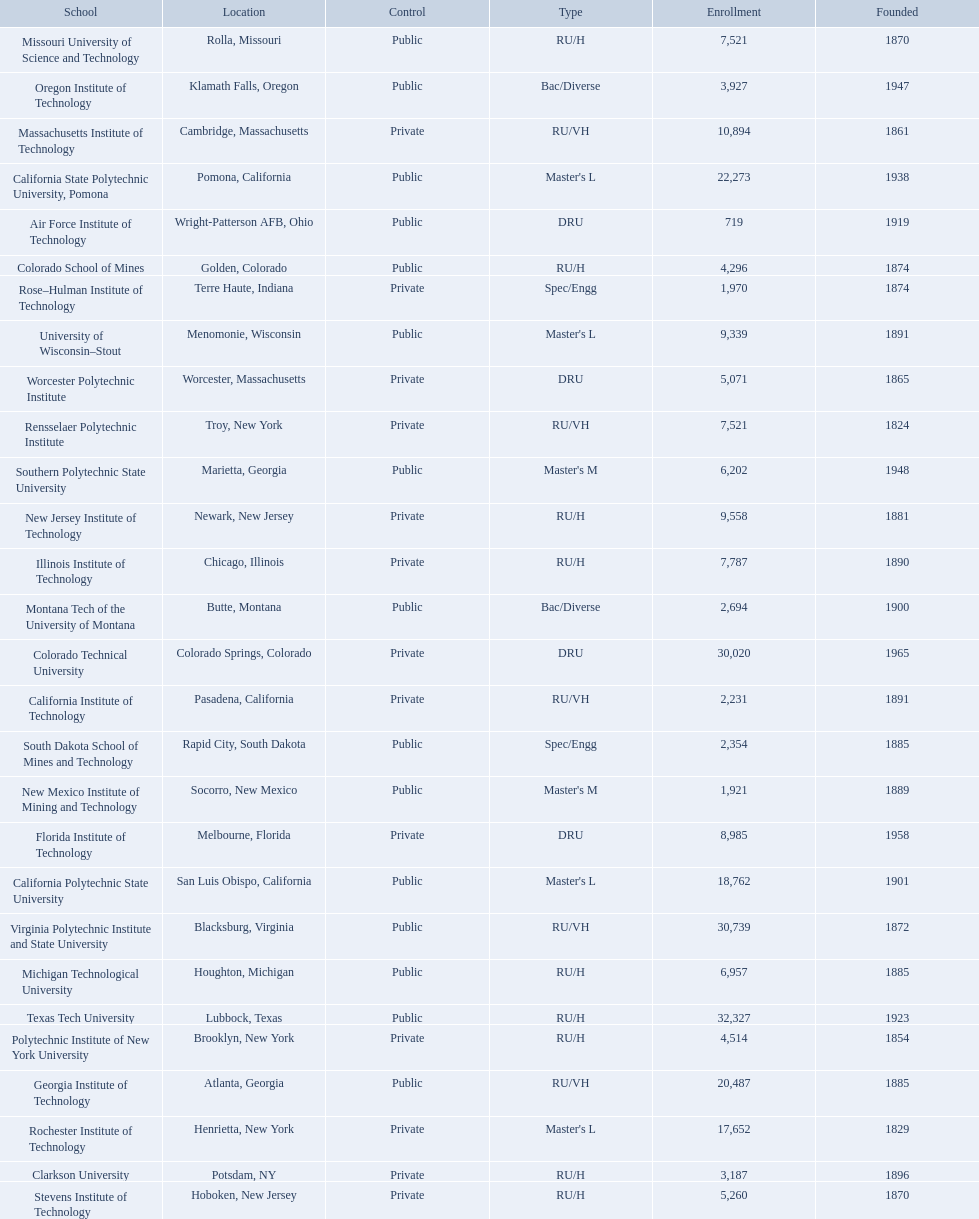What are the listed enrollment numbers of us universities? 719, 2,231, 18,762, 22,273, 3,187, 4,296, 30,020, 8,985, 20,487, 7,787, 10,894, 6,957, 7,521, 2,694, 9,558, 1,921, 3,927, 4,514, 7,521, 17,652, 1,970, 2,354, 6,202, 5,260, 32,327, 9,339, 30,739, 5,071. Of these, which has the highest value? 32,327. What are the listed names of us universities? Air Force Institute of Technology, California Institute of Technology, California Polytechnic State University, California State Polytechnic University, Pomona, Clarkson University, Colorado School of Mines, Colorado Technical University, Florida Institute of Technology, Georgia Institute of Technology, Illinois Institute of Technology, Massachusetts Institute of Technology, Michigan Technological University, Missouri University of Science and Technology, Montana Tech of the University of Montana, New Jersey Institute of Technology, New Mexico Institute of Mining and Technology, Oregon Institute of Technology, Polytechnic Institute of New York University, Rensselaer Polytechnic Institute, Rochester Institute of Technology, Rose–Hulman Institute of Technology, South Dakota School of Mines and Technology, Southern Polytechnic State University, Stevens Institute of Technology, Texas Tech University, University of Wisconsin–Stout, Virginia Polytechnic Institute and State University, Worcester Polytechnic Institute. Which of these correspond to the previously listed highest enrollment value? Texas Tech University. 